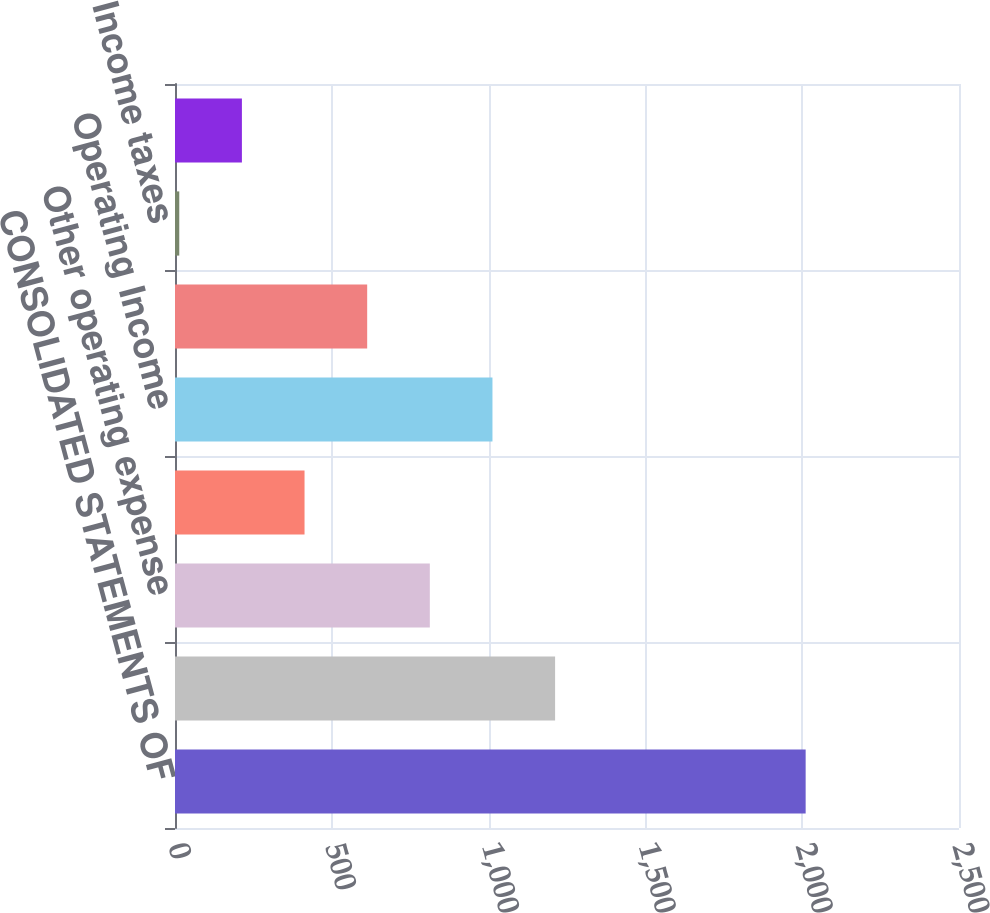<chart> <loc_0><loc_0><loc_500><loc_500><bar_chart><fcel>CONSOLIDATED STATEMENTS OF<fcel>Revenues<fcel>Other operating expense<fcel>Provision for depreciation<fcel>Operating Income<fcel>Income before income taxes<fcel>Income taxes<fcel>Net Income<nl><fcel>2011<fcel>1212.04<fcel>812.56<fcel>413.08<fcel>1012.3<fcel>612.82<fcel>13.6<fcel>213.34<nl></chart> 